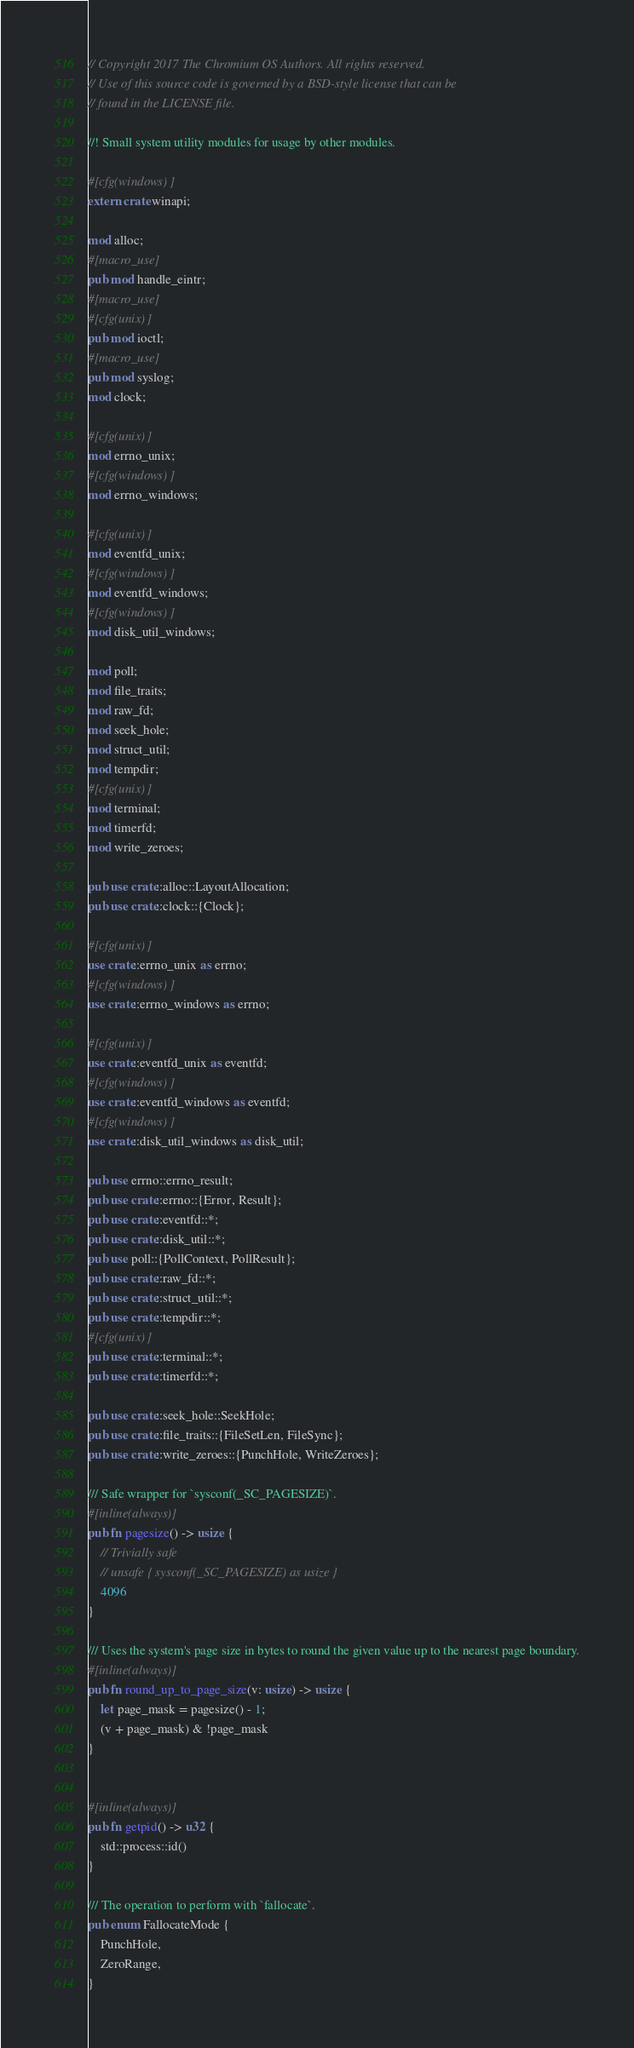<code> <loc_0><loc_0><loc_500><loc_500><_Rust_>// Copyright 2017 The Chromium OS Authors. All rights reserved.
// Use of this source code is governed by a BSD-style license that can be
// found in the LICENSE file.

//! Small system utility modules for usage by other modules.

#[cfg(windows)]
extern crate winapi;

mod alloc;
#[macro_use]
pub mod handle_eintr;
#[macro_use]
#[cfg(unix)]
pub mod ioctl;
#[macro_use]
pub mod syslog;
mod clock;

#[cfg(unix)]
mod errno_unix;
#[cfg(windows)]
mod errno_windows;

#[cfg(unix)]
mod eventfd_unix;
#[cfg(windows)]
mod eventfd_windows;
#[cfg(windows)]
mod disk_util_windows;

mod poll;
mod file_traits;
mod raw_fd;
mod seek_hole;
mod struct_util;
mod tempdir;
#[cfg(unix)]
mod terminal;
mod timerfd;
mod write_zeroes;

pub use crate::alloc::LayoutAllocation;
pub use crate::clock::{Clock};

#[cfg(unix)]
use crate::errno_unix as errno;
#[cfg(windows)]
use crate::errno_windows as errno;

#[cfg(unix)]
use crate::eventfd_unix as eventfd;
#[cfg(windows)]
use crate::eventfd_windows as eventfd;
#[cfg(windows)]
use crate::disk_util_windows as disk_util;

pub use errno::errno_result;
pub use crate::errno::{Error, Result};
pub use crate::eventfd::*;
pub use crate::disk_util::*;
pub use poll::{PollContext, PollResult};
pub use crate::raw_fd::*;
pub use crate::struct_util::*;
pub use crate::tempdir::*;
#[cfg(unix)]
pub use crate::terminal::*;
pub use crate::timerfd::*;

pub use crate::seek_hole::SeekHole;
pub use crate::file_traits::{FileSetLen, FileSync};
pub use crate::write_zeroes::{PunchHole, WriteZeroes};

/// Safe wrapper for `sysconf(_SC_PAGESIZE)`.
#[inline(always)]
pub fn pagesize() -> usize {
    // Trivially safe
    // unsafe { sysconf(_SC_PAGESIZE) as usize }
    4096
}

/// Uses the system's page size in bytes to round the given value up to the nearest page boundary.
#[inline(always)]
pub fn round_up_to_page_size(v: usize) -> usize {
    let page_mask = pagesize() - 1;
    (v + page_mask) & !page_mask
}


#[inline(always)]
pub fn getpid() -> u32 {
    std::process::id()
}

/// The operation to perform with `fallocate`.
pub enum FallocateMode {
    PunchHole,
    ZeroRange,
}
</code> 